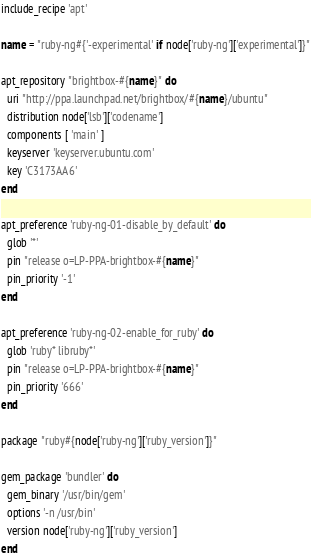<code> <loc_0><loc_0><loc_500><loc_500><_Ruby_>include_recipe 'apt'

name = "ruby-ng#{'-experimental' if node['ruby-ng']['experimental']}"

apt_repository "brightbox-#{name}" do
  uri "http://ppa.launchpad.net/brightbox/#{name}/ubuntu"
  distribution node['lsb']['codename']
  components [ 'main' ]
  keyserver 'keyserver.ubuntu.com'
  key 'C3173AA6'
end

apt_preference 'ruby-ng-01-disable_by_default' do
  glob '*'
  pin "release o=LP-PPA-brightbox-#{name}"
  pin_priority '-1'
end

apt_preference 'ruby-ng-02-enable_for_ruby' do
  glob 'ruby* libruby*'
  pin "release o=LP-PPA-brightbox-#{name}"
  pin_priority '666'
end

package "ruby#{node['ruby-ng']['ruby_version']}"

gem_package 'bundler' do
  gem_binary '/usr/bin/gem'
  options '-n /usr/bin'
  version node['ruby-ng']['ruby_version']
end
</code> 